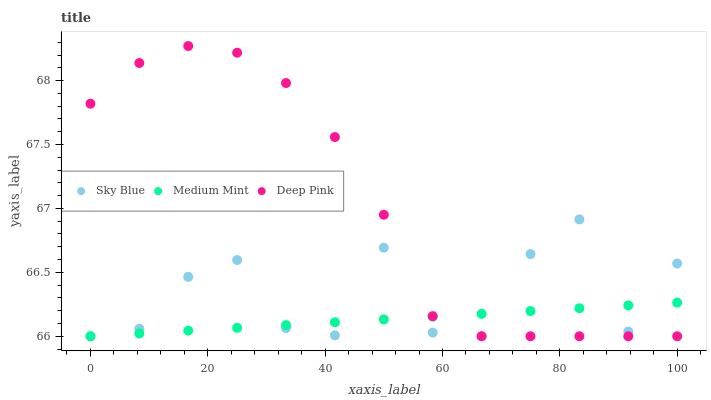Does Medium Mint have the minimum area under the curve?
Answer yes or no. Yes. Does Deep Pink have the maximum area under the curve?
Answer yes or no. Yes. Does Sky Blue have the minimum area under the curve?
Answer yes or no. No. Does Sky Blue have the maximum area under the curve?
Answer yes or no. No. Is Medium Mint the smoothest?
Answer yes or no. Yes. Is Sky Blue the roughest?
Answer yes or no. Yes. Is Deep Pink the smoothest?
Answer yes or no. No. Is Deep Pink the roughest?
Answer yes or no. No. Does Medium Mint have the lowest value?
Answer yes or no. Yes. Does Deep Pink have the highest value?
Answer yes or no. Yes. Does Sky Blue have the highest value?
Answer yes or no. No. Does Deep Pink intersect Medium Mint?
Answer yes or no. Yes. Is Deep Pink less than Medium Mint?
Answer yes or no. No. Is Deep Pink greater than Medium Mint?
Answer yes or no. No. 